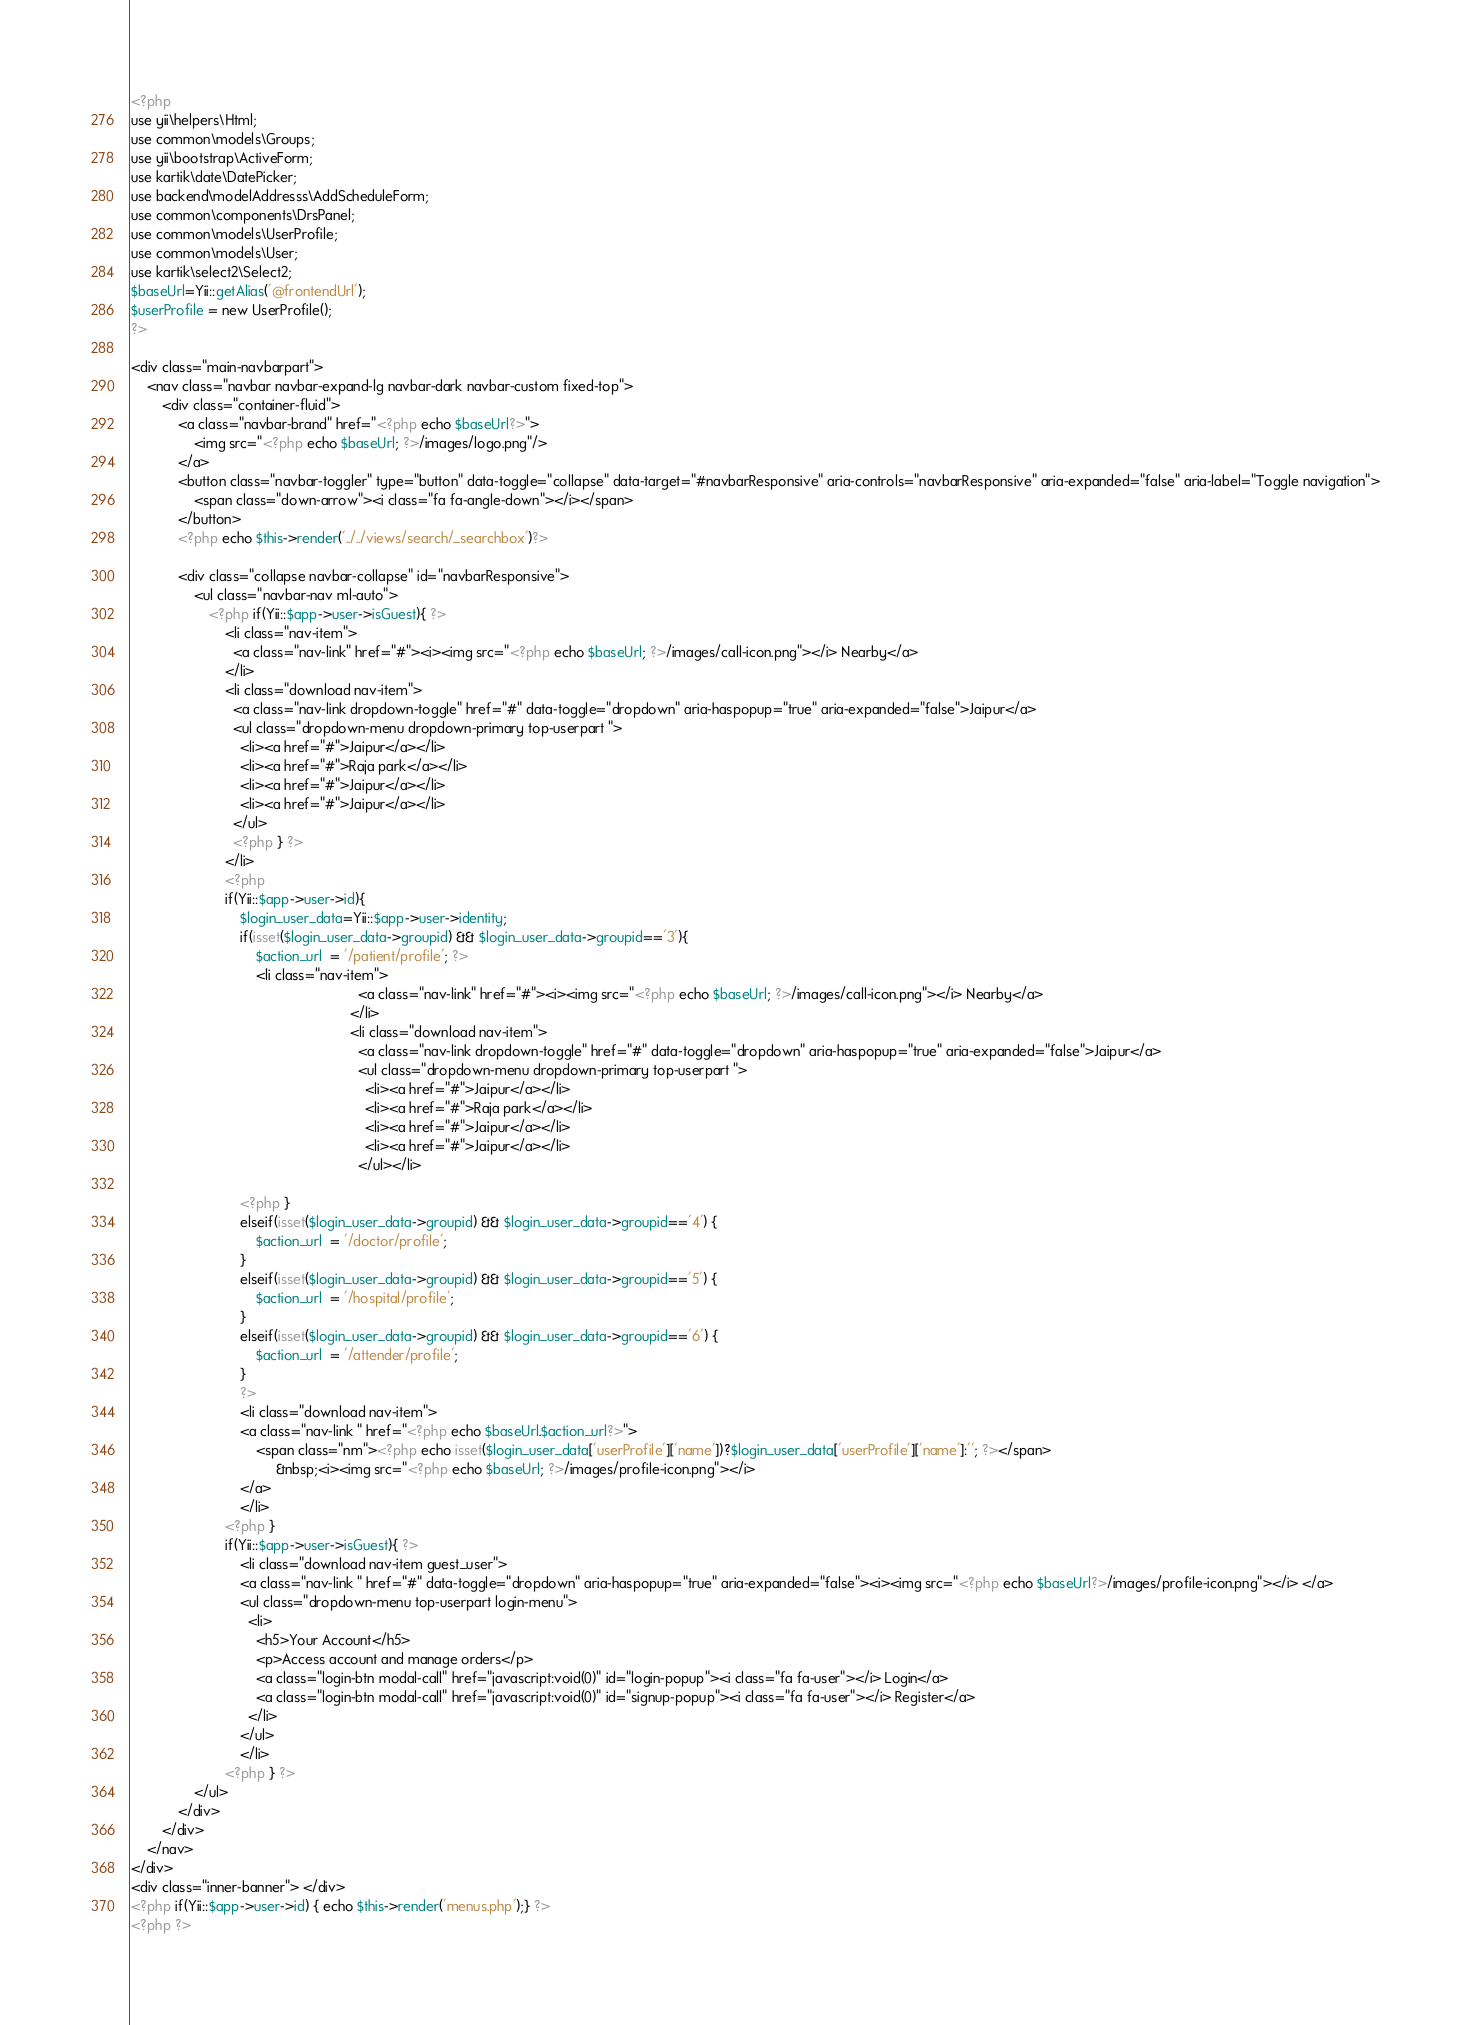<code> <loc_0><loc_0><loc_500><loc_500><_PHP_><?php
use yii\helpers\Html;
use common\models\Groups;
use yii\bootstrap\ActiveForm;
use kartik\date\DatePicker;
use backend\modelAddresss\AddScheduleForm;
use common\components\DrsPanel;
use common\models\UserProfile;
use common\models\User;
use kartik\select2\Select2;
$baseUrl=Yii::getAlias('@frontendUrl');
$userProfile = new UserProfile();
?>

<div class="main-navbarpart">
    <nav class="navbar navbar-expand-lg navbar-dark navbar-custom fixed-top">
        <div class="container-fluid">
            <a class="navbar-brand" href="<?php echo $baseUrl?>">
                <img src="<?php echo $baseUrl; ?>/images/logo.png"/>
            </a>
            <button class="navbar-toggler" type="button" data-toggle="collapse" data-target="#navbarResponsive" aria-controls="navbarResponsive" aria-expanded="false" aria-label="Toggle navigation">
                <span class="down-arrow"><i class="fa fa-angle-down"></i></span>
            </button>
            <?php echo $this->render('../../views/search/_searchbox')?>
     
            <div class="collapse navbar-collapse" id="navbarResponsive">
                <ul class="navbar-nav ml-auto">
                    <?php if(Yii::$app->user->isGuest){ ?>
                        <li class="nav-item">
                          <a class="nav-link" href="#"><i><img src="<?php echo $baseUrl; ?>/images/call-icon.png"></i> Nearby</a>
                        </li>
                        <li class="download nav-item">
                          <a class="nav-link dropdown-toggle" href="#" data-toggle="dropdown" aria-haspopup="true" aria-expanded="false">Jaipur</a>
                          <ul class="dropdown-menu dropdown-primary top-userpart ">
                            <li><a href="#">Jaipur</a></li>
                            <li><a href="#">Raja park</a></li>
                            <li><a href="#">Jaipur</a></li>
                            <li><a href="#">Jaipur</a></li>
                          </ul>
                          <?php } ?>
                        </li>
                        <?php
                        if(Yii::$app->user->id){
                            $login_user_data=Yii::$app->user->identity;
                            if(isset($login_user_data->groupid) && $login_user_data->groupid=='3'){
                                $action_url  = '/patient/profile'; ?>
                                <li class="nav-item">
                                                          <a class="nav-link" href="#"><i><img src="<?php echo $baseUrl; ?>/images/call-icon.png"></i> Nearby</a>
                                                        </li>
                                                        <li class="download nav-item">
                                                          <a class="nav-link dropdown-toggle" href="#" data-toggle="dropdown" aria-haspopup="true" aria-expanded="false">Jaipur</a>
                                                          <ul class="dropdown-menu dropdown-primary top-userpart ">
                                                            <li><a href="#">Jaipur</a></li>
                                                            <li><a href="#">Raja park</a></li>
                                                            <li><a href="#">Jaipur</a></li>
                                                            <li><a href="#">Jaipur</a></li>
                                                          </ul></li>

                            <?php }
                            elseif(isset($login_user_data->groupid) && $login_user_data->groupid=='4') {
                                $action_url  = '/doctor/profile';
                            }
                            elseif(isset($login_user_data->groupid) && $login_user_data->groupid=='5') {
                                $action_url  = '/hospital/profile';
                            } 
                            elseif(isset($login_user_data->groupid) && $login_user_data->groupid=='6') {
                                $action_url  = '/attender/profile';
                            }
                            ?>
                            <li class="download nav-item">
                            <a class="nav-link " href="<?php echo $baseUrl.$action_url?>">
                                <span class="nm"><?php echo isset($login_user_data['userProfile']['name'])?$login_user_data['userProfile']['name']:''; ?></span>
                                     &nbsp;<i><img src="<?php echo $baseUrl; ?>/images/profile-icon.png"></i>
                            </a>
                            </li>
                        <?php }
                        if(Yii::$app->user->isGuest){ ?>
                            <li class="download nav-item guest_user">
                            <a class="nav-link " href="#" data-toggle="dropdown" aria-haspopup="true" aria-expanded="false"><i><img src="<?php echo $baseUrl?>/images/profile-icon.png"></i> </a>
                            <ul class="dropdown-menu top-userpart login-menu">
                              <li>
                                <h5>Your Account</h5>
                                <p>Access account and manage orders</p>
                                <a class="login-btn modal-call" href="javascript:void(0)" id="login-popup"><i class="fa fa-user"></i> Login</a>
                                <a class="login-btn modal-call" href="javascript:void(0)" id="signup-popup"><i class="fa fa-user"></i> Register</a>
                              </li>
                            </ul>
                            </li>
                        <?php } ?>
                </ul>
            </div>
        </div>
    </nav>
</div>
<div class="inner-banner"> </div>
<?php if(Yii::$app->user->id) { echo $this->render('menus.php');} ?>
<?php ?>
</code> 